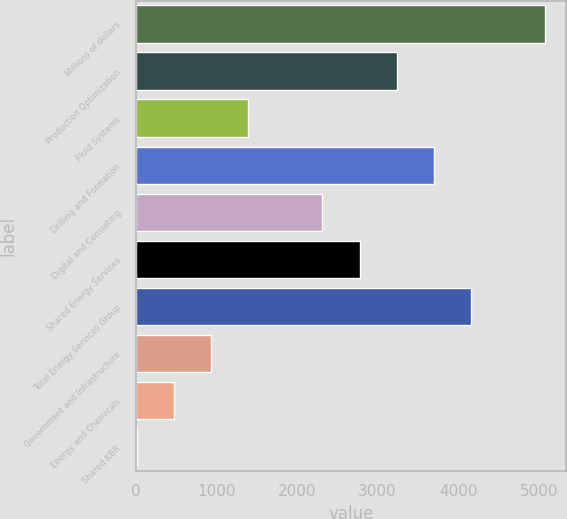Convert chart to OTSL. <chart><loc_0><loc_0><loc_500><loc_500><bar_chart><fcel>Millions of dollars<fcel>Production Optimization<fcel>Fluid Systems<fcel>Drilling and Formation<fcel>Digital and Consulting<fcel>Shared Energy Services<fcel>Total Energy Services Group<fcel>Government and Infrastructure<fcel>Energy and Chemicals<fcel>Shared KBR<nl><fcel>5080.8<fcel>3237.6<fcel>1394.4<fcel>3698.4<fcel>2316<fcel>2776.8<fcel>4159.2<fcel>933.6<fcel>472.8<fcel>12<nl></chart> 